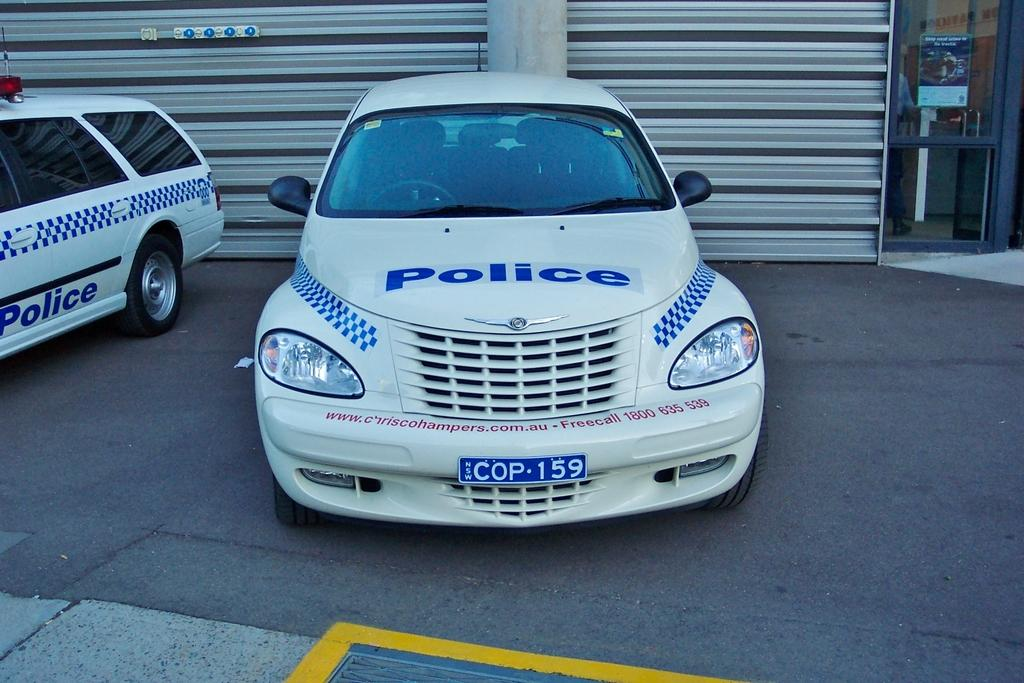<image>
Provide a brief description of the given image. A police car sitting in front of a garage. 